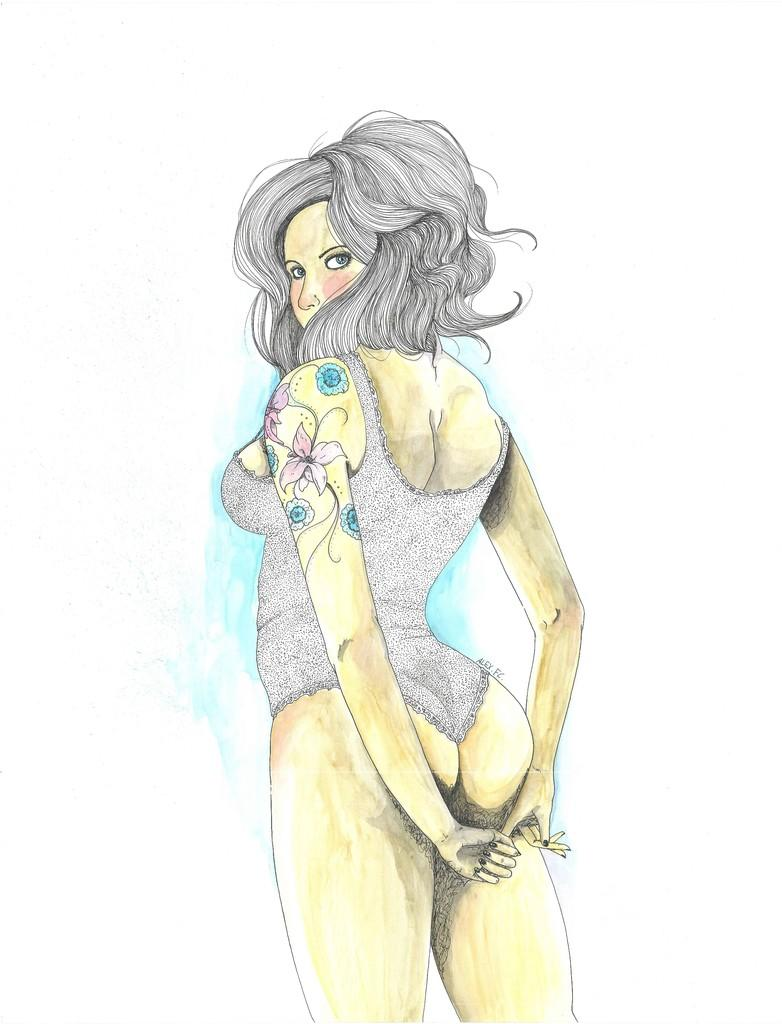What is the main subject of the image? The image contains a painting. What is the painting depicting? The painting depicts a woman in a bikini. What is the woman in the painting doing with her hands? The woman is standing with both hands behind her back. What color is the background of the painting? The background of the painting is white in color. What type of feast is being suggested in the painting? There is no feast or suggestion of a feast present in the painting; it depicts a woman in a bikini standing with both hands behind her back against a white background. 